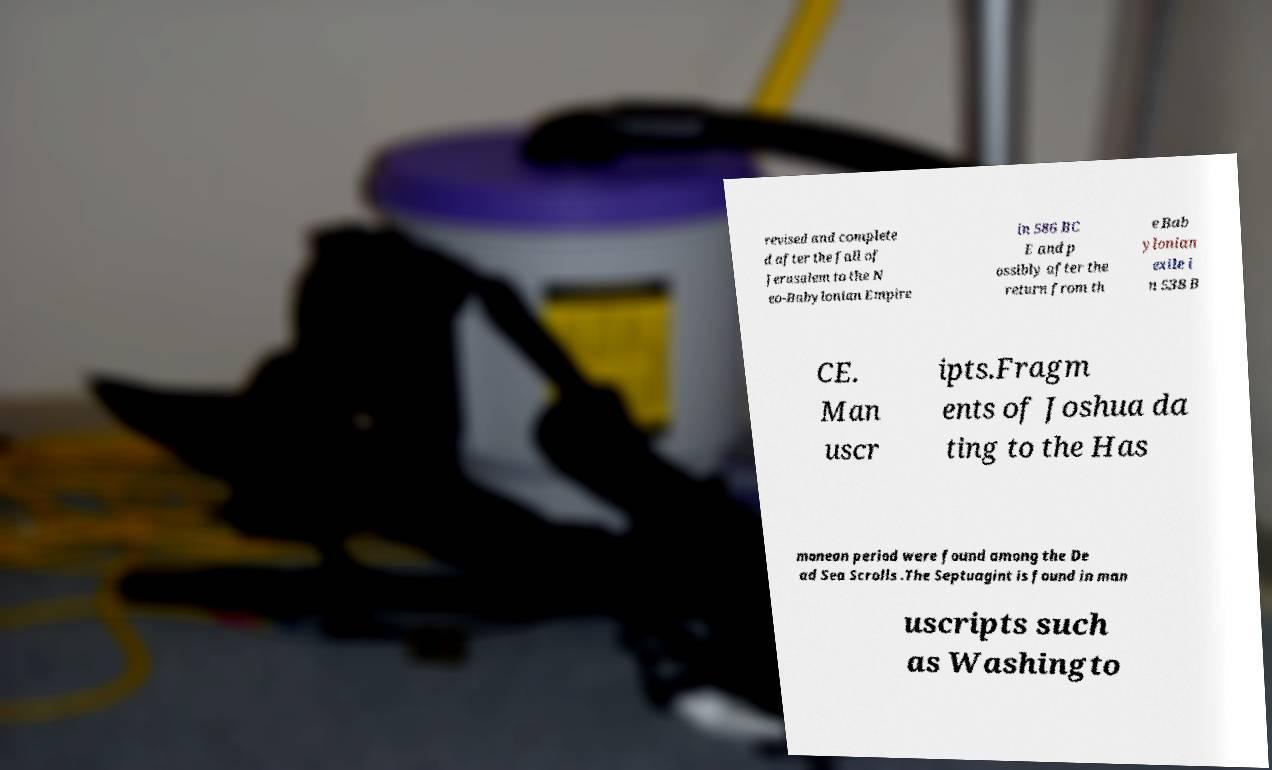Can you accurately transcribe the text from the provided image for me? revised and complete d after the fall of Jerusalem to the N eo-Babylonian Empire in 586 BC E and p ossibly after the return from th e Bab ylonian exile i n 538 B CE. Man uscr ipts.Fragm ents of Joshua da ting to the Has monean period were found among the De ad Sea Scrolls .The Septuagint is found in man uscripts such as Washingto 